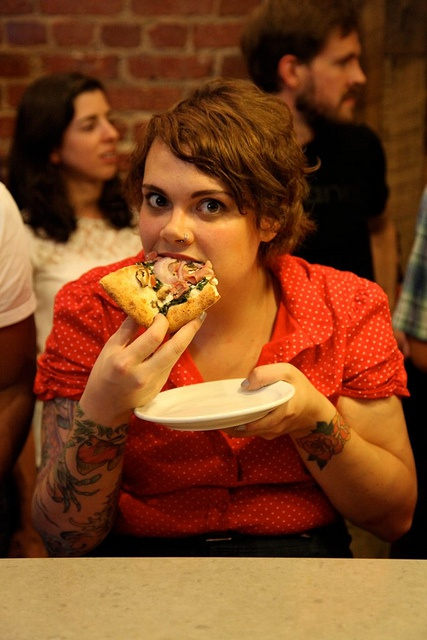Describe the objects in this image and their specific colors. I can see people in maroon, black, brown, and red tones, dining table in maroon, tan, and black tones, people in maroon, black, and brown tones, people in maroon, black, tan, and brown tones, and people in maroon, black, and tan tones in this image. 